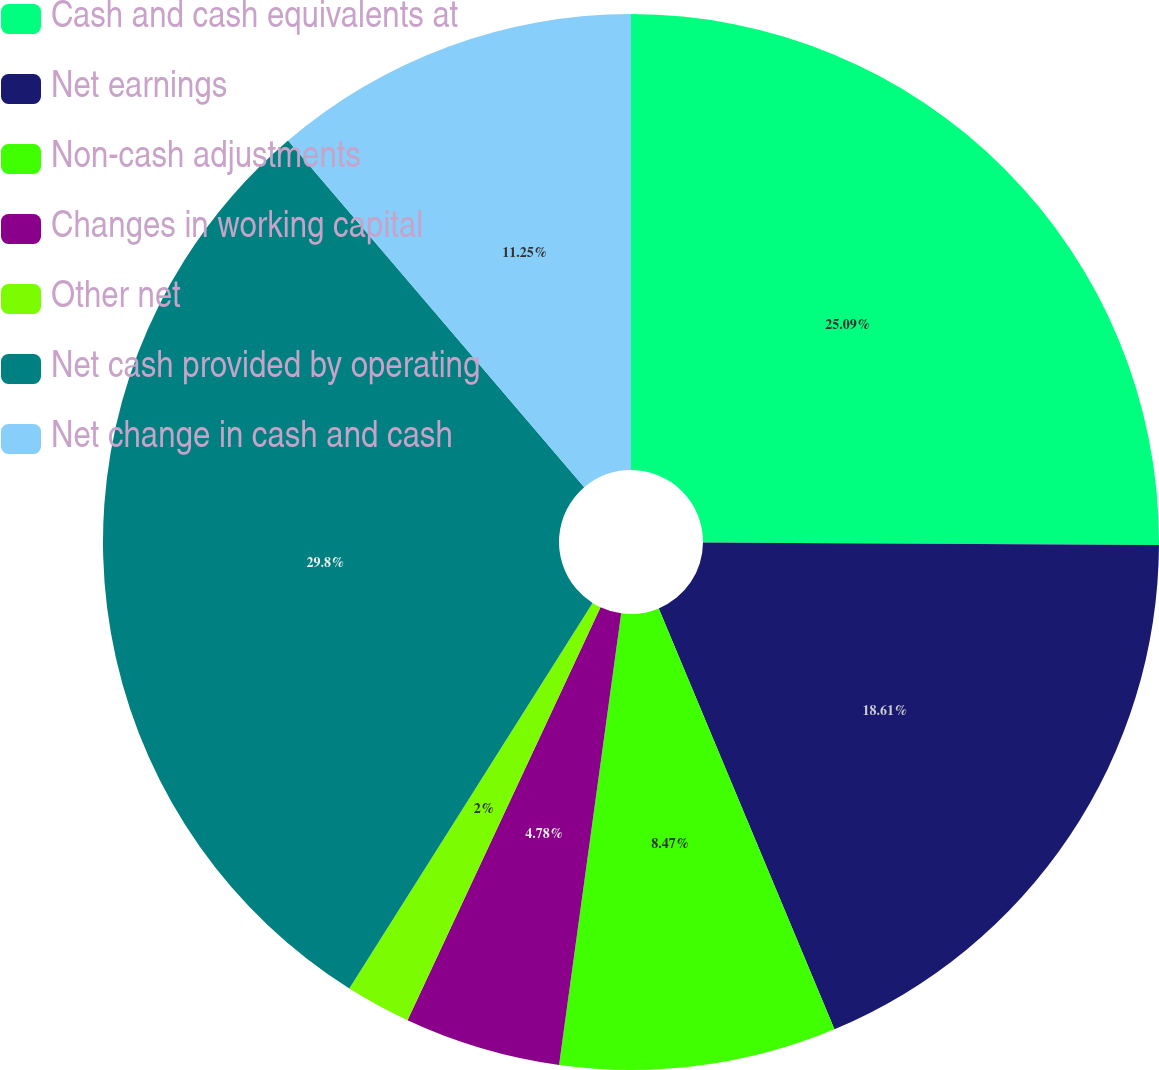<chart> <loc_0><loc_0><loc_500><loc_500><pie_chart><fcel>Cash and cash equivalents at<fcel>Net earnings<fcel>Non-cash adjustments<fcel>Changes in working capital<fcel>Other net<fcel>Net cash provided by operating<fcel>Net change in cash and cash<nl><fcel>25.09%<fcel>18.61%<fcel>8.47%<fcel>4.78%<fcel>2.0%<fcel>29.79%<fcel>11.25%<nl></chart> 